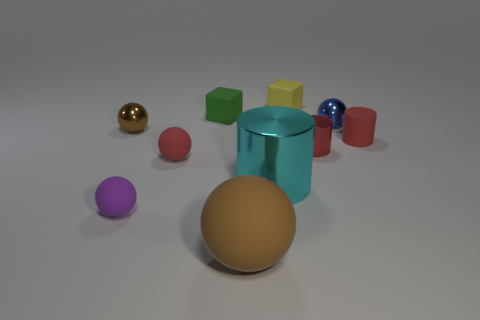Subtract 2 balls. How many balls are left? 3 Subtract all blue spheres. How many spheres are left? 4 Subtract all blue shiny balls. How many balls are left? 4 Subtract all cyan balls. Subtract all cyan cylinders. How many balls are left? 5 Subtract all blocks. How many objects are left? 8 Subtract all small matte balls. Subtract all big spheres. How many objects are left? 7 Add 9 small blue metallic spheres. How many small blue metallic spheres are left? 10 Add 5 purple metal things. How many purple metal things exist? 5 Subtract 0 blue cubes. How many objects are left? 10 